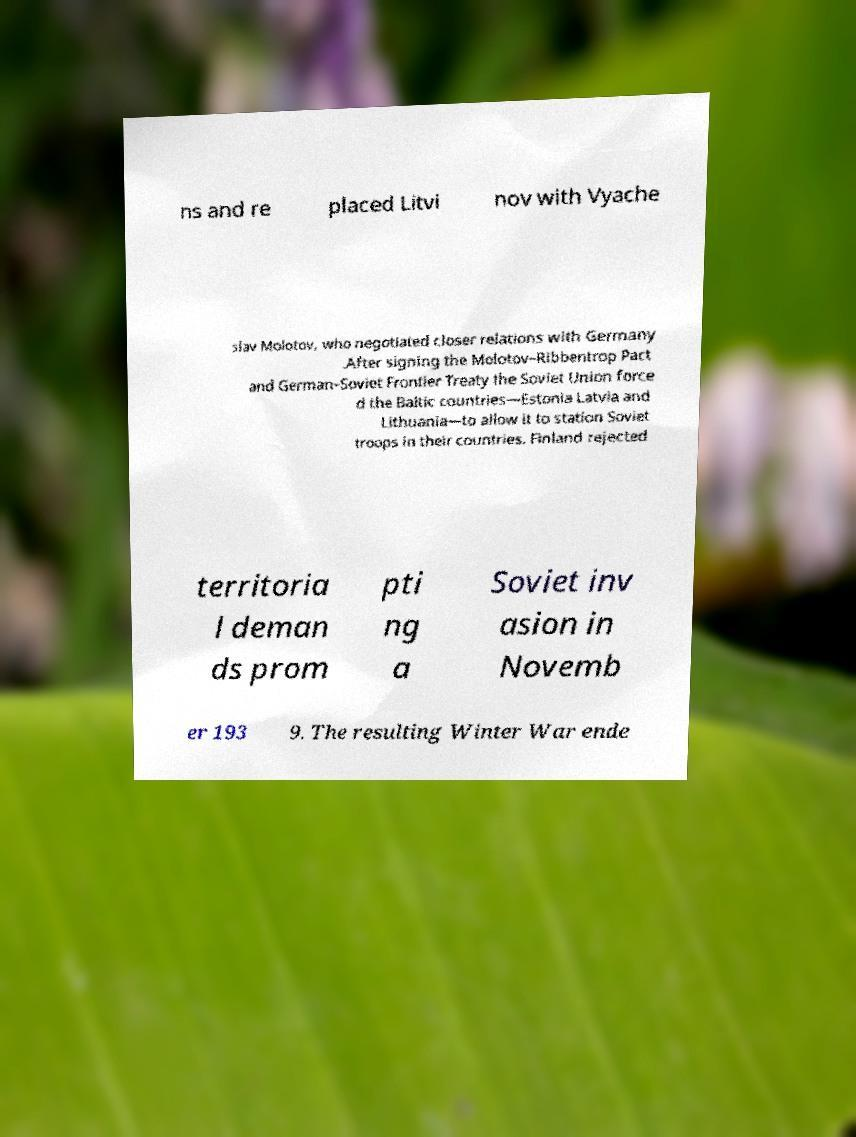Please identify and transcribe the text found in this image. ns and re placed Litvi nov with Vyache slav Molotov, who negotiated closer relations with Germany .After signing the Molotov–Ribbentrop Pact and German–Soviet Frontier Treaty the Soviet Union force d the Baltic countries—Estonia Latvia and Lithuania—to allow it to station Soviet troops in their countries. Finland rejected territoria l deman ds prom pti ng a Soviet inv asion in Novemb er 193 9. The resulting Winter War ende 